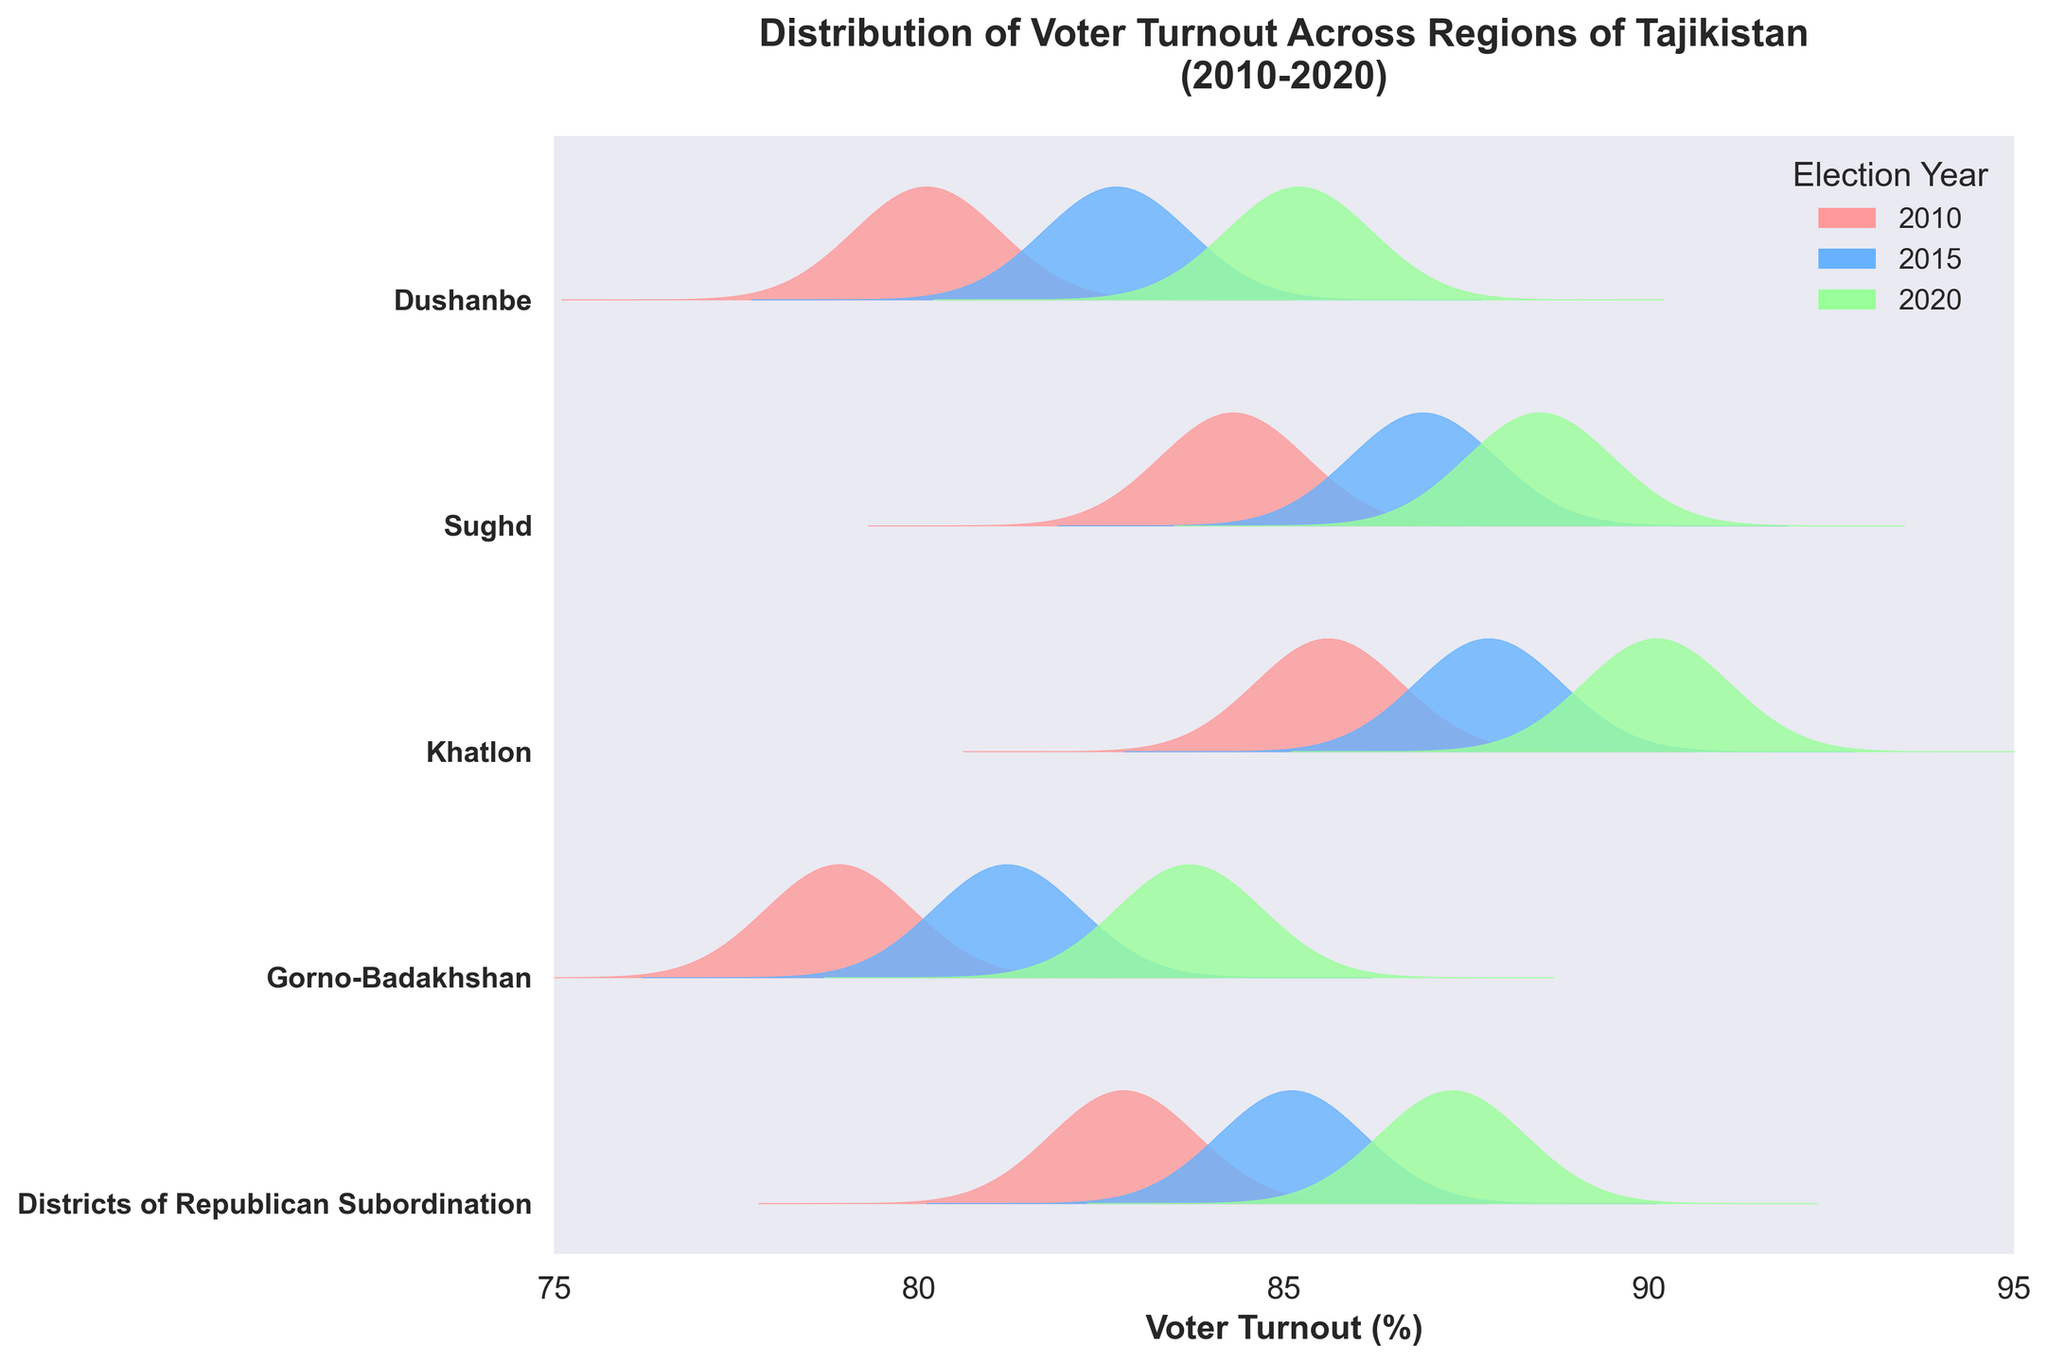What's the title of the plot? The title is usually located at the top of the plot and provides a brief description of what the plot is about. Here, the title clearly states, "Distribution of Voter Turnout Across Regions of Tajikistan (2010-2020)."
Answer: Distribution of Voter Turnout Across Regions of Tajikistan (2010-2020) Which region had the highest voter turnout in 2020? Look for the lines with the highest peaks specific to 2020 (color-coded) across all regions. The highest peak indicates the highest voter turnout. For 2020, Khatlon has the highest peak.
Answer: Khatlon How does voter turnout in Dushanbe compare across the three election years? Examine the ridgeline plot for Dushanbe. Observe the positions and heights of the peaks for the years 2010, 2015, and 2020. Notice how they progressively increase across these years.
Answer: It increased from 80.1% in 2010 to 82.7% in 2015, and further to 85.2% in 2020 In which year did Sughd region see the highest voter turnout? Identify the ridgeline for the Sughd region. Then, compare the three peaks that correspond to different years and note which one is the highest.
Answer: 2020 Is the voter turnout in Khatlon greater in 2015 or 2020? Examine the ridgeline plot for Khatlon specifically for the years 2015 and 2020. Compare the heights of the peaks to determine which is taller.
Answer: 2020 What is the overall trend in voter turnout for Gorno-Badakhshan from 2010 to 2020? Look at the ridgeline plots for Gorno-Badakhshan across the three years. Notice if there is an upward or downward trend in the peaks.
Answer: Upward trend How does the voter turnout distribution in Districts of Republican Subordination for 2010 compare to 2015? Compare the ridgeline plots for Districts of Republican Subordination for the years 2010 and 2015. Look for the overall shape, peak positions, and heights to see the differences.
Answer: It increased from 82.8% in 2010 to 85.1% in 2015 Which region shows the smallest increase in voter turnout from 2010 to 2020? Calculate the change in voter turnout for each region from 2010 to 2020 and compare these changes. The smallest difference indicates the smallest increase.
Answer: Gorno-Badakhshan Which election year is represented by the blue shade in the ridgeline plot? Examine the legend provided for the plot. It links colors to specific election years, identifying which color represents which year.
Answer: 2015 